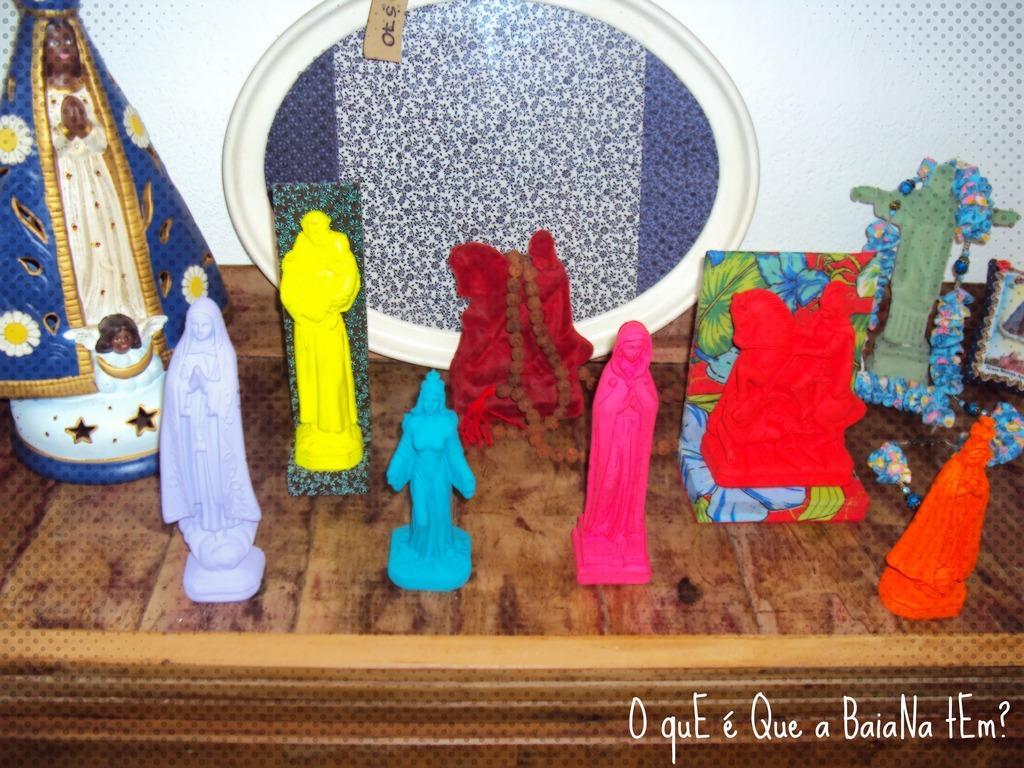Describe this image in one or two sentences. In this image I can see the brown colored surface and on it I can see few toys which are yellow, blue, pink, orange, cream and green in color and I can see a frame which is blue and white in color. I can see the white colored wall in the background. 